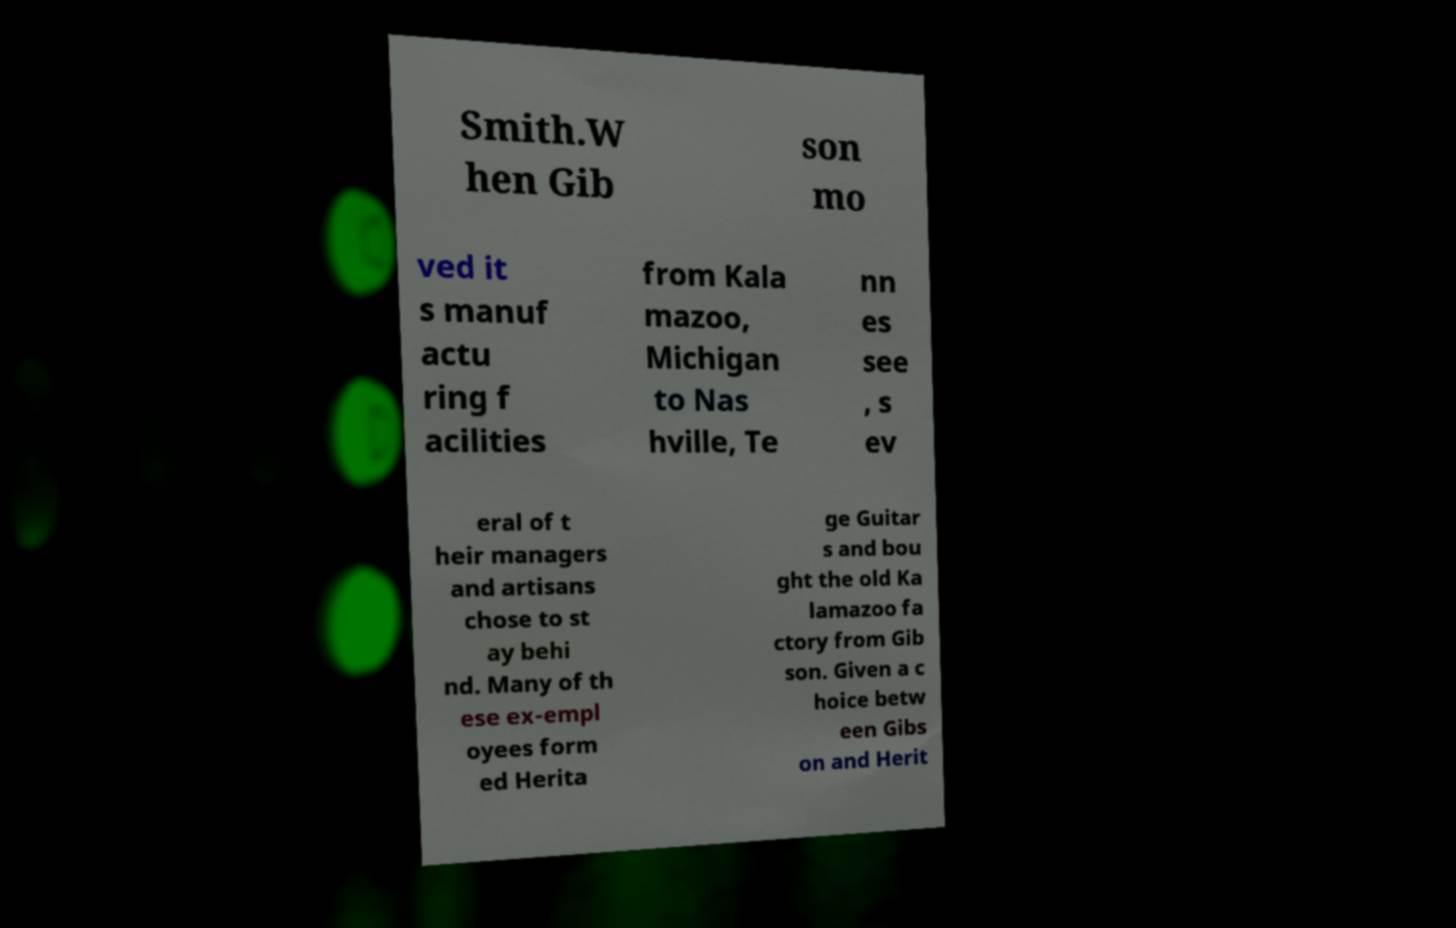There's text embedded in this image that I need extracted. Can you transcribe it verbatim? Smith.W hen Gib son mo ved it s manuf actu ring f acilities from Kala mazoo, Michigan to Nas hville, Te nn es see , s ev eral of t heir managers and artisans chose to st ay behi nd. Many of th ese ex-empl oyees form ed Herita ge Guitar s and bou ght the old Ka lamazoo fa ctory from Gib son. Given a c hoice betw een Gibs on and Herit 